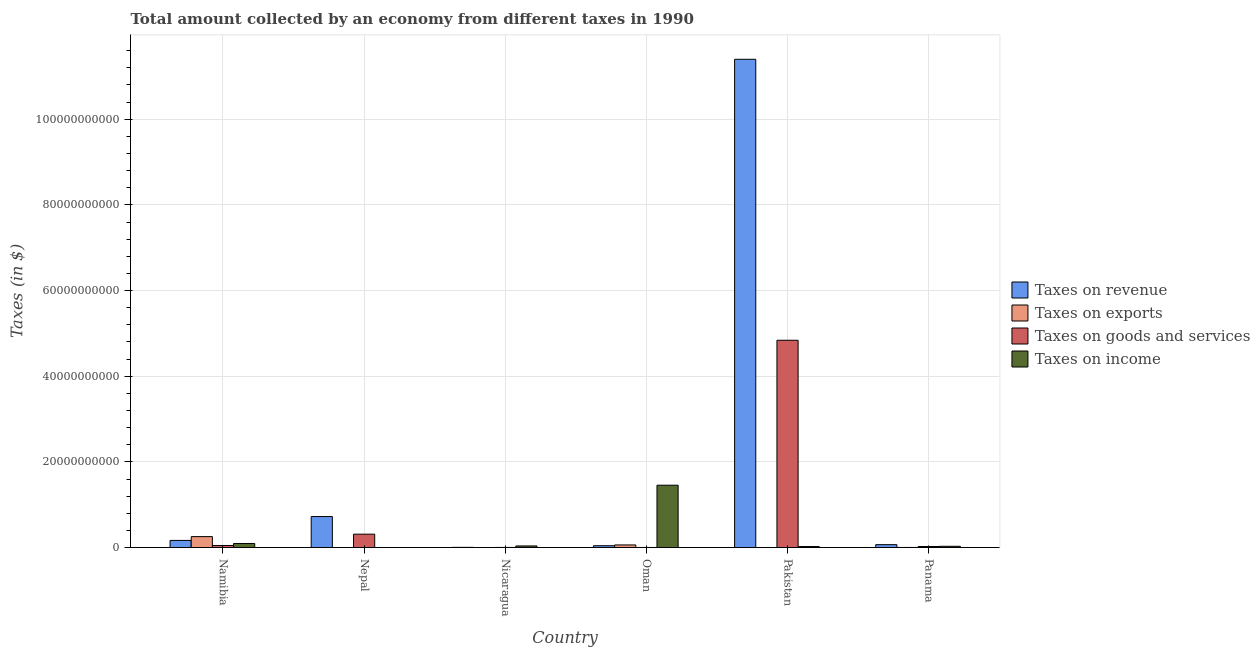How many different coloured bars are there?
Offer a terse response. 4. Are the number of bars per tick equal to the number of legend labels?
Make the answer very short. Yes. How many bars are there on the 5th tick from the right?
Your answer should be compact. 4. What is the label of the 6th group of bars from the left?
Your response must be concise. Panama. In how many cases, is the number of bars for a given country not equal to the number of legend labels?
Keep it short and to the point. 0. What is the amount collected as tax on income in Panama?
Your answer should be compact. 2.90e+08. Across all countries, what is the maximum amount collected as tax on income?
Ensure brevity in your answer.  1.46e+1. Across all countries, what is the minimum amount collected as tax on goods?
Provide a short and direct response. 1.10e+07. In which country was the amount collected as tax on exports minimum?
Make the answer very short. Nepal. What is the total amount collected as tax on goods in the graph?
Keep it short and to the point. 5.23e+1. What is the difference between the amount collected as tax on goods in Nepal and that in Pakistan?
Keep it short and to the point. -4.53e+1. What is the difference between the amount collected as tax on revenue in Oman and the amount collected as tax on exports in Nicaragua?
Give a very brief answer. 4.18e+08. What is the average amount collected as tax on exports per country?
Provide a succinct answer. 5.30e+08. What is the difference between the amount collected as tax on exports and amount collected as tax on income in Namibia?
Provide a succinct answer. 1.61e+09. In how many countries, is the amount collected as tax on goods greater than 32000000000 $?
Your answer should be very brief. 1. What is the ratio of the amount collected as tax on exports in Nicaragua to that in Panama?
Provide a succinct answer. 0.21. Is the difference between the amount collected as tax on income in Namibia and Oman greater than the difference between the amount collected as tax on goods in Namibia and Oman?
Your response must be concise. No. What is the difference between the highest and the second highest amount collected as tax on income?
Ensure brevity in your answer.  1.36e+1. What is the difference between the highest and the lowest amount collected as tax on exports?
Keep it short and to the point. 2.55e+09. In how many countries, is the amount collected as tax on exports greater than the average amount collected as tax on exports taken over all countries?
Your answer should be very brief. 2. What does the 1st bar from the left in Pakistan represents?
Give a very brief answer. Taxes on revenue. What does the 2nd bar from the right in Namibia represents?
Give a very brief answer. Taxes on goods and services. Are all the bars in the graph horizontal?
Your answer should be compact. No. How many countries are there in the graph?
Your answer should be compact. 6. Where does the legend appear in the graph?
Give a very brief answer. Center right. How many legend labels are there?
Provide a short and direct response. 4. What is the title of the graph?
Give a very brief answer. Total amount collected by an economy from different taxes in 1990. Does "Plant species" appear as one of the legend labels in the graph?
Ensure brevity in your answer.  No. What is the label or title of the X-axis?
Keep it short and to the point. Country. What is the label or title of the Y-axis?
Keep it short and to the point. Taxes (in $). What is the Taxes (in $) of Taxes on revenue in Namibia?
Ensure brevity in your answer.  1.66e+09. What is the Taxes (in $) in Taxes on exports in Namibia?
Your answer should be very brief. 2.55e+09. What is the Taxes (in $) of Taxes on goods and services in Namibia?
Provide a short and direct response. 4.80e+08. What is the Taxes (in $) in Taxes on income in Namibia?
Offer a very short reply. 9.43e+08. What is the Taxes (in $) of Taxes on revenue in Nepal?
Your answer should be very brief. 7.24e+09. What is the Taxes (in $) of Taxes on exports in Nepal?
Your answer should be very brief. 1.21e+06. What is the Taxes (in $) of Taxes on goods and services in Nepal?
Keep it short and to the point. 3.12e+09. What is the Taxes (in $) of Taxes on income in Nepal?
Ensure brevity in your answer.  9.16e+06. What is the Taxes (in $) of Taxes on revenue in Nicaragua?
Keep it short and to the point. 4.11e+07. What is the Taxes (in $) of Taxes on exports in Nicaragua?
Make the answer very short. 2.90e+06. What is the Taxes (in $) in Taxes on goods and services in Nicaragua?
Offer a terse response. 1.82e+07. What is the Taxes (in $) in Taxes on income in Nicaragua?
Ensure brevity in your answer.  3.68e+08. What is the Taxes (in $) of Taxes on revenue in Oman?
Provide a succinct answer. 4.21e+08. What is the Taxes (in $) in Taxes on exports in Oman?
Provide a succinct answer. 6.04e+08. What is the Taxes (in $) of Taxes on goods and services in Oman?
Offer a very short reply. 1.10e+07. What is the Taxes (in $) in Taxes on income in Oman?
Offer a very short reply. 1.46e+1. What is the Taxes (in $) in Taxes on revenue in Pakistan?
Give a very brief answer. 1.14e+11. What is the Taxes (in $) in Taxes on exports in Pakistan?
Provide a short and direct response. 9.40e+06. What is the Taxes (in $) in Taxes on goods and services in Pakistan?
Provide a short and direct response. 4.84e+1. What is the Taxes (in $) of Taxes on income in Pakistan?
Your answer should be very brief. 2.29e+08. What is the Taxes (in $) in Taxes on revenue in Panama?
Your answer should be very brief. 6.70e+08. What is the Taxes (in $) in Taxes on exports in Panama?
Provide a succinct answer. 1.40e+07. What is the Taxes (in $) of Taxes on goods and services in Panama?
Provide a short and direct response. 2.33e+08. What is the Taxes (in $) in Taxes on income in Panama?
Offer a terse response. 2.90e+08. Across all countries, what is the maximum Taxes (in $) in Taxes on revenue?
Your answer should be very brief. 1.14e+11. Across all countries, what is the maximum Taxes (in $) in Taxes on exports?
Offer a terse response. 2.55e+09. Across all countries, what is the maximum Taxes (in $) of Taxes on goods and services?
Your answer should be very brief. 4.84e+1. Across all countries, what is the maximum Taxes (in $) in Taxes on income?
Ensure brevity in your answer.  1.46e+1. Across all countries, what is the minimum Taxes (in $) of Taxes on revenue?
Your response must be concise. 4.11e+07. Across all countries, what is the minimum Taxes (in $) of Taxes on exports?
Keep it short and to the point. 1.21e+06. Across all countries, what is the minimum Taxes (in $) of Taxes on goods and services?
Provide a succinct answer. 1.10e+07. Across all countries, what is the minimum Taxes (in $) in Taxes on income?
Keep it short and to the point. 9.16e+06. What is the total Taxes (in $) of Taxes on revenue in the graph?
Ensure brevity in your answer.  1.24e+11. What is the total Taxes (in $) in Taxes on exports in the graph?
Provide a short and direct response. 3.18e+09. What is the total Taxes (in $) of Taxes on goods and services in the graph?
Keep it short and to the point. 5.23e+1. What is the total Taxes (in $) in Taxes on income in the graph?
Your answer should be very brief. 1.64e+1. What is the difference between the Taxes (in $) of Taxes on revenue in Namibia and that in Nepal?
Provide a short and direct response. -5.57e+09. What is the difference between the Taxes (in $) in Taxes on exports in Namibia and that in Nepal?
Provide a short and direct response. 2.55e+09. What is the difference between the Taxes (in $) of Taxes on goods and services in Namibia and that in Nepal?
Provide a short and direct response. -2.64e+09. What is the difference between the Taxes (in $) in Taxes on income in Namibia and that in Nepal?
Offer a very short reply. 9.34e+08. What is the difference between the Taxes (in $) of Taxes on revenue in Namibia and that in Nicaragua?
Offer a terse response. 1.62e+09. What is the difference between the Taxes (in $) in Taxes on exports in Namibia and that in Nicaragua?
Offer a very short reply. 2.55e+09. What is the difference between the Taxes (in $) in Taxes on goods and services in Namibia and that in Nicaragua?
Give a very brief answer. 4.61e+08. What is the difference between the Taxes (in $) in Taxes on income in Namibia and that in Nicaragua?
Offer a very short reply. 5.75e+08. What is the difference between the Taxes (in $) in Taxes on revenue in Namibia and that in Oman?
Give a very brief answer. 1.24e+09. What is the difference between the Taxes (in $) of Taxes on exports in Namibia and that in Oman?
Provide a succinct answer. 1.94e+09. What is the difference between the Taxes (in $) in Taxes on goods and services in Namibia and that in Oman?
Offer a very short reply. 4.68e+08. What is the difference between the Taxes (in $) of Taxes on income in Namibia and that in Oman?
Ensure brevity in your answer.  -1.36e+1. What is the difference between the Taxes (in $) of Taxes on revenue in Namibia and that in Pakistan?
Provide a short and direct response. -1.12e+11. What is the difference between the Taxes (in $) in Taxes on exports in Namibia and that in Pakistan?
Make the answer very short. 2.54e+09. What is the difference between the Taxes (in $) of Taxes on goods and services in Namibia and that in Pakistan?
Provide a short and direct response. -4.79e+1. What is the difference between the Taxes (in $) of Taxes on income in Namibia and that in Pakistan?
Provide a succinct answer. 7.14e+08. What is the difference between the Taxes (in $) in Taxes on revenue in Namibia and that in Panama?
Offer a terse response. 9.91e+08. What is the difference between the Taxes (in $) in Taxes on exports in Namibia and that in Panama?
Offer a terse response. 2.54e+09. What is the difference between the Taxes (in $) in Taxes on goods and services in Namibia and that in Panama?
Keep it short and to the point. 2.47e+08. What is the difference between the Taxes (in $) of Taxes on income in Namibia and that in Panama?
Provide a succinct answer. 6.53e+08. What is the difference between the Taxes (in $) of Taxes on revenue in Nepal and that in Nicaragua?
Make the answer very short. 7.19e+09. What is the difference between the Taxes (in $) of Taxes on exports in Nepal and that in Nicaragua?
Make the answer very short. -1.69e+06. What is the difference between the Taxes (in $) of Taxes on goods and services in Nepal and that in Nicaragua?
Offer a very short reply. 3.10e+09. What is the difference between the Taxes (in $) of Taxes on income in Nepal and that in Nicaragua?
Offer a very short reply. -3.59e+08. What is the difference between the Taxes (in $) in Taxes on revenue in Nepal and that in Oman?
Keep it short and to the point. 6.82e+09. What is the difference between the Taxes (in $) of Taxes on exports in Nepal and that in Oman?
Your answer should be very brief. -6.03e+08. What is the difference between the Taxes (in $) of Taxes on goods and services in Nepal and that in Oman?
Offer a very short reply. 3.11e+09. What is the difference between the Taxes (in $) of Taxes on income in Nepal and that in Oman?
Your response must be concise. -1.45e+1. What is the difference between the Taxes (in $) in Taxes on revenue in Nepal and that in Pakistan?
Provide a succinct answer. -1.07e+11. What is the difference between the Taxes (in $) in Taxes on exports in Nepal and that in Pakistan?
Keep it short and to the point. -8.19e+06. What is the difference between the Taxes (in $) of Taxes on goods and services in Nepal and that in Pakistan?
Provide a succinct answer. -4.53e+1. What is the difference between the Taxes (in $) in Taxes on income in Nepal and that in Pakistan?
Provide a succinct answer. -2.20e+08. What is the difference between the Taxes (in $) in Taxes on revenue in Nepal and that in Panama?
Give a very brief answer. 6.57e+09. What is the difference between the Taxes (in $) in Taxes on exports in Nepal and that in Panama?
Your response must be concise. -1.28e+07. What is the difference between the Taxes (in $) in Taxes on goods and services in Nepal and that in Panama?
Offer a terse response. 2.89e+09. What is the difference between the Taxes (in $) in Taxes on income in Nepal and that in Panama?
Make the answer very short. -2.81e+08. What is the difference between the Taxes (in $) in Taxes on revenue in Nicaragua and that in Oman?
Your answer should be very brief. -3.80e+08. What is the difference between the Taxes (in $) in Taxes on exports in Nicaragua and that in Oman?
Make the answer very short. -6.01e+08. What is the difference between the Taxes (in $) in Taxes on goods and services in Nicaragua and that in Oman?
Provide a short and direct response. 7.18e+06. What is the difference between the Taxes (in $) in Taxes on income in Nicaragua and that in Oman?
Offer a terse response. -1.42e+1. What is the difference between the Taxes (in $) in Taxes on revenue in Nicaragua and that in Pakistan?
Offer a very short reply. -1.14e+11. What is the difference between the Taxes (in $) of Taxes on exports in Nicaragua and that in Pakistan?
Keep it short and to the point. -6.50e+06. What is the difference between the Taxes (in $) of Taxes on goods and services in Nicaragua and that in Pakistan?
Provide a succinct answer. -4.84e+1. What is the difference between the Taxes (in $) in Taxes on income in Nicaragua and that in Pakistan?
Make the answer very short. 1.39e+08. What is the difference between the Taxes (in $) in Taxes on revenue in Nicaragua and that in Panama?
Your answer should be very brief. -6.29e+08. What is the difference between the Taxes (in $) in Taxes on exports in Nicaragua and that in Panama?
Offer a very short reply. -1.11e+07. What is the difference between the Taxes (in $) in Taxes on goods and services in Nicaragua and that in Panama?
Provide a succinct answer. -2.14e+08. What is the difference between the Taxes (in $) of Taxes on income in Nicaragua and that in Panama?
Give a very brief answer. 7.82e+07. What is the difference between the Taxes (in $) in Taxes on revenue in Oman and that in Pakistan?
Provide a short and direct response. -1.14e+11. What is the difference between the Taxes (in $) of Taxes on exports in Oman and that in Pakistan?
Your response must be concise. 5.95e+08. What is the difference between the Taxes (in $) in Taxes on goods and services in Oman and that in Pakistan?
Your answer should be compact. -4.84e+1. What is the difference between the Taxes (in $) in Taxes on income in Oman and that in Pakistan?
Offer a very short reply. 1.43e+1. What is the difference between the Taxes (in $) of Taxes on revenue in Oman and that in Panama?
Make the answer very short. -2.49e+08. What is the difference between the Taxes (in $) in Taxes on exports in Oman and that in Panama?
Make the answer very short. 5.90e+08. What is the difference between the Taxes (in $) of Taxes on goods and services in Oman and that in Panama?
Offer a terse response. -2.22e+08. What is the difference between the Taxes (in $) of Taxes on income in Oman and that in Panama?
Make the answer very short. 1.43e+1. What is the difference between the Taxes (in $) of Taxes on revenue in Pakistan and that in Panama?
Provide a short and direct response. 1.13e+11. What is the difference between the Taxes (in $) of Taxes on exports in Pakistan and that in Panama?
Ensure brevity in your answer.  -4.60e+06. What is the difference between the Taxes (in $) of Taxes on goods and services in Pakistan and that in Panama?
Your answer should be very brief. 4.82e+1. What is the difference between the Taxes (in $) of Taxes on income in Pakistan and that in Panama?
Make the answer very short. -6.08e+07. What is the difference between the Taxes (in $) in Taxes on revenue in Namibia and the Taxes (in $) in Taxes on exports in Nepal?
Make the answer very short. 1.66e+09. What is the difference between the Taxes (in $) in Taxes on revenue in Namibia and the Taxes (in $) in Taxes on goods and services in Nepal?
Provide a succinct answer. -1.46e+09. What is the difference between the Taxes (in $) in Taxes on revenue in Namibia and the Taxes (in $) in Taxes on income in Nepal?
Your answer should be compact. 1.65e+09. What is the difference between the Taxes (in $) in Taxes on exports in Namibia and the Taxes (in $) in Taxes on goods and services in Nepal?
Offer a terse response. -5.70e+08. What is the difference between the Taxes (in $) of Taxes on exports in Namibia and the Taxes (in $) of Taxes on income in Nepal?
Give a very brief answer. 2.54e+09. What is the difference between the Taxes (in $) of Taxes on goods and services in Namibia and the Taxes (in $) of Taxes on income in Nepal?
Make the answer very short. 4.70e+08. What is the difference between the Taxes (in $) in Taxes on revenue in Namibia and the Taxes (in $) in Taxes on exports in Nicaragua?
Provide a short and direct response. 1.66e+09. What is the difference between the Taxes (in $) of Taxes on revenue in Namibia and the Taxes (in $) of Taxes on goods and services in Nicaragua?
Offer a terse response. 1.64e+09. What is the difference between the Taxes (in $) of Taxes on revenue in Namibia and the Taxes (in $) of Taxes on income in Nicaragua?
Your answer should be compact. 1.29e+09. What is the difference between the Taxes (in $) of Taxes on exports in Namibia and the Taxes (in $) of Taxes on goods and services in Nicaragua?
Your answer should be compact. 2.53e+09. What is the difference between the Taxes (in $) of Taxes on exports in Namibia and the Taxes (in $) of Taxes on income in Nicaragua?
Your answer should be very brief. 2.18e+09. What is the difference between the Taxes (in $) in Taxes on goods and services in Namibia and the Taxes (in $) in Taxes on income in Nicaragua?
Provide a succinct answer. 1.11e+08. What is the difference between the Taxes (in $) in Taxes on revenue in Namibia and the Taxes (in $) in Taxes on exports in Oman?
Your response must be concise. 1.06e+09. What is the difference between the Taxes (in $) in Taxes on revenue in Namibia and the Taxes (in $) in Taxes on goods and services in Oman?
Ensure brevity in your answer.  1.65e+09. What is the difference between the Taxes (in $) of Taxes on revenue in Namibia and the Taxes (in $) of Taxes on income in Oman?
Your answer should be compact. -1.29e+1. What is the difference between the Taxes (in $) in Taxes on exports in Namibia and the Taxes (in $) in Taxes on goods and services in Oman?
Offer a very short reply. 2.54e+09. What is the difference between the Taxes (in $) in Taxes on exports in Namibia and the Taxes (in $) in Taxes on income in Oman?
Make the answer very short. -1.20e+1. What is the difference between the Taxes (in $) in Taxes on goods and services in Namibia and the Taxes (in $) in Taxes on income in Oman?
Keep it short and to the point. -1.41e+1. What is the difference between the Taxes (in $) in Taxes on revenue in Namibia and the Taxes (in $) in Taxes on exports in Pakistan?
Give a very brief answer. 1.65e+09. What is the difference between the Taxes (in $) in Taxes on revenue in Namibia and the Taxes (in $) in Taxes on goods and services in Pakistan?
Give a very brief answer. -4.67e+1. What is the difference between the Taxes (in $) in Taxes on revenue in Namibia and the Taxes (in $) in Taxes on income in Pakistan?
Your answer should be compact. 1.43e+09. What is the difference between the Taxes (in $) of Taxes on exports in Namibia and the Taxes (in $) of Taxes on goods and services in Pakistan?
Offer a very short reply. -4.58e+1. What is the difference between the Taxes (in $) of Taxes on exports in Namibia and the Taxes (in $) of Taxes on income in Pakistan?
Offer a very short reply. 2.32e+09. What is the difference between the Taxes (in $) of Taxes on goods and services in Namibia and the Taxes (in $) of Taxes on income in Pakistan?
Your response must be concise. 2.50e+08. What is the difference between the Taxes (in $) of Taxes on revenue in Namibia and the Taxes (in $) of Taxes on exports in Panama?
Provide a succinct answer. 1.65e+09. What is the difference between the Taxes (in $) in Taxes on revenue in Namibia and the Taxes (in $) in Taxes on goods and services in Panama?
Provide a short and direct response. 1.43e+09. What is the difference between the Taxes (in $) of Taxes on revenue in Namibia and the Taxes (in $) of Taxes on income in Panama?
Keep it short and to the point. 1.37e+09. What is the difference between the Taxes (in $) of Taxes on exports in Namibia and the Taxes (in $) of Taxes on goods and services in Panama?
Ensure brevity in your answer.  2.32e+09. What is the difference between the Taxes (in $) of Taxes on exports in Namibia and the Taxes (in $) of Taxes on income in Panama?
Give a very brief answer. 2.26e+09. What is the difference between the Taxes (in $) in Taxes on goods and services in Namibia and the Taxes (in $) in Taxes on income in Panama?
Give a very brief answer. 1.89e+08. What is the difference between the Taxes (in $) of Taxes on revenue in Nepal and the Taxes (in $) of Taxes on exports in Nicaragua?
Your answer should be very brief. 7.23e+09. What is the difference between the Taxes (in $) in Taxes on revenue in Nepal and the Taxes (in $) in Taxes on goods and services in Nicaragua?
Provide a succinct answer. 7.22e+09. What is the difference between the Taxes (in $) of Taxes on revenue in Nepal and the Taxes (in $) of Taxes on income in Nicaragua?
Your answer should be very brief. 6.87e+09. What is the difference between the Taxes (in $) in Taxes on exports in Nepal and the Taxes (in $) in Taxes on goods and services in Nicaragua?
Give a very brief answer. -1.70e+07. What is the difference between the Taxes (in $) of Taxes on exports in Nepal and the Taxes (in $) of Taxes on income in Nicaragua?
Offer a terse response. -3.67e+08. What is the difference between the Taxes (in $) of Taxes on goods and services in Nepal and the Taxes (in $) of Taxes on income in Nicaragua?
Offer a terse response. 2.75e+09. What is the difference between the Taxes (in $) of Taxes on revenue in Nepal and the Taxes (in $) of Taxes on exports in Oman?
Give a very brief answer. 6.63e+09. What is the difference between the Taxes (in $) in Taxes on revenue in Nepal and the Taxes (in $) in Taxes on goods and services in Oman?
Your answer should be very brief. 7.22e+09. What is the difference between the Taxes (in $) in Taxes on revenue in Nepal and the Taxes (in $) in Taxes on income in Oman?
Provide a succinct answer. -7.32e+09. What is the difference between the Taxes (in $) in Taxes on exports in Nepal and the Taxes (in $) in Taxes on goods and services in Oman?
Your answer should be very brief. -9.79e+06. What is the difference between the Taxes (in $) of Taxes on exports in Nepal and the Taxes (in $) of Taxes on income in Oman?
Keep it short and to the point. -1.45e+1. What is the difference between the Taxes (in $) of Taxes on goods and services in Nepal and the Taxes (in $) of Taxes on income in Oman?
Ensure brevity in your answer.  -1.14e+1. What is the difference between the Taxes (in $) in Taxes on revenue in Nepal and the Taxes (in $) in Taxes on exports in Pakistan?
Ensure brevity in your answer.  7.23e+09. What is the difference between the Taxes (in $) of Taxes on revenue in Nepal and the Taxes (in $) of Taxes on goods and services in Pakistan?
Provide a succinct answer. -4.12e+1. What is the difference between the Taxes (in $) of Taxes on revenue in Nepal and the Taxes (in $) of Taxes on income in Pakistan?
Offer a very short reply. 7.01e+09. What is the difference between the Taxes (in $) of Taxes on exports in Nepal and the Taxes (in $) of Taxes on goods and services in Pakistan?
Give a very brief answer. -4.84e+1. What is the difference between the Taxes (in $) in Taxes on exports in Nepal and the Taxes (in $) in Taxes on income in Pakistan?
Offer a very short reply. -2.28e+08. What is the difference between the Taxes (in $) of Taxes on goods and services in Nepal and the Taxes (in $) of Taxes on income in Pakistan?
Offer a terse response. 2.89e+09. What is the difference between the Taxes (in $) of Taxes on revenue in Nepal and the Taxes (in $) of Taxes on exports in Panama?
Your response must be concise. 7.22e+09. What is the difference between the Taxes (in $) of Taxes on revenue in Nepal and the Taxes (in $) of Taxes on goods and services in Panama?
Offer a very short reply. 7.00e+09. What is the difference between the Taxes (in $) of Taxes on revenue in Nepal and the Taxes (in $) of Taxes on income in Panama?
Give a very brief answer. 6.95e+09. What is the difference between the Taxes (in $) of Taxes on exports in Nepal and the Taxes (in $) of Taxes on goods and services in Panama?
Provide a succinct answer. -2.31e+08. What is the difference between the Taxes (in $) in Taxes on exports in Nepal and the Taxes (in $) in Taxes on income in Panama?
Keep it short and to the point. -2.89e+08. What is the difference between the Taxes (in $) of Taxes on goods and services in Nepal and the Taxes (in $) of Taxes on income in Panama?
Your response must be concise. 2.83e+09. What is the difference between the Taxes (in $) of Taxes on revenue in Nicaragua and the Taxes (in $) of Taxes on exports in Oman?
Give a very brief answer. -5.63e+08. What is the difference between the Taxes (in $) of Taxes on revenue in Nicaragua and the Taxes (in $) of Taxes on goods and services in Oman?
Offer a terse response. 3.01e+07. What is the difference between the Taxes (in $) in Taxes on revenue in Nicaragua and the Taxes (in $) in Taxes on income in Oman?
Ensure brevity in your answer.  -1.45e+1. What is the difference between the Taxes (in $) of Taxes on exports in Nicaragua and the Taxes (in $) of Taxes on goods and services in Oman?
Offer a terse response. -8.10e+06. What is the difference between the Taxes (in $) in Taxes on exports in Nicaragua and the Taxes (in $) in Taxes on income in Oman?
Offer a very short reply. -1.45e+1. What is the difference between the Taxes (in $) of Taxes on goods and services in Nicaragua and the Taxes (in $) of Taxes on income in Oman?
Your answer should be very brief. -1.45e+1. What is the difference between the Taxes (in $) of Taxes on revenue in Nicaragua and the Taxes (in $) of Taxes on exports in Pakistan?
Your answer should be very brief. 3.17e+07. What is the difference between the Taxes (in $) of Taxes on revenue in Nicaragua and the Taxes (in $) of Taxes on goods and services in Pakistan?
Your answer should be very brief. -4.84e+1. What is the difference between the Taxes (in $) in Taxes on revenue in Nicaragua and the Taxes (in $) in Taxes on income in Pakistan?
Your answer should be compact. -1.88e+08. What is the difference between the Taxes (in $) of Taxes on exports in Nicaragua and the Taxes (in $) of Taxes on goods and services in Pakistan?
Offer a very short reply. -4.84e+1. What is the difference between the Taxes (in $) in Taxes on exports in Nicaragua and the Taxes (in $) in Taxes on income in Pakistan?
Your answer should be compact. -2.26e+08. What is the difference between the Taxes (in $) of Taxes on goods and services in Nicaragua and the Taxes (in $) of Taxes on income in Pakistan?
Keep it short and to the point. -2.11e+08. What is the difference between the Taxes (in $) in Taxes on revenue in Nicaragua and the Taxes (in $) in Taxes on exports in Panama?
Keep it short and to the point. 2.71e+07. What is the difference between the Taxes (in $) in Taxes on revenue in Nicaragua and the Taxes (in $) in Taxes on goods and services in Panama?
Provide a succinct answer. -1.92e+08. What is the difference between the Taxes (in $) of Taxes on revenue in Nicaragua and the Taxes (in $) of Taxes on income in Panama?
Provide a succinct answer. -2.49e+08. What is the difference between the Taxes (in $) of Taxes on exports in Nicaragua and the Taxes (in $) of Taxes on goods and services in Panama?
Give a very brief answer. -2.30e+08. What is the difference between the Taxes (in $) in Taxes on exports in Nicaragua and the Taxes (in $) in Taxes on income in Panama?
Your answer should be compact. -2.87e+08. What is the difference between the Taxes (in $) in Taxes on goods and services in Nicaragua and the Taxes (in $) in Taxes on income in Panama?
Keep it short and to the point. -2.72e+08. What is the difference between the Taxes (in $) in Taxes on revenue in Oman and the Taxes (in $) in Taxes on exports in Pakistan?
Your response must be concise. 4.11e+08. What is the difference between the Taxes (in $) of Taxes on revenue in Oman and the Taxes (in $) of Taxes on goods and services in Pakistan?
Give a very brief answer. -4.80e+1. What is the difference between the Taxes (in $) in Taxes on revenue in Oman and the Taxes (in $) in Taxes on income in Pakistan?
Offer a terse response. 1.91e+08. What is the difference between the Taxes (in $) of Taxes on exports in Oman and the Taxes (in $) of Taxes on goods and services in Pakistan?
Offer a very short reply. -4.78e+1. What is the difference between the Taxes (in $) of Taxes on exports in Oman and the Taxes (in $) of Taxes on income in Pakistan?
Offer a very short reply. 3.75e+08. What is the difference between the Taxes (in $) of Taxes on goods and services in Oman and the Taxes (in $) of Taxes on income in Pakistan?
Ensure brevity in your answer.  -2.18e+08. What is the difference between the Taxes (in $) in Taxes on revenue in Oman and the Taxes (in $) in Taxes on exports in Panama?
Provide a succinct answer. 4.07e+08. What is the difference between the Taxes (in $) in Taxes on revenue in Oman and the Taxes (in $) in Taxes on goods and services in Panama?
Provide a short and direct response. 1.88e+08. What is the difference between the Taxes (in $) of Taxes on revenue in Oman and the Taxes (in $) of Taxes on income in Panama?
Your answer should be very brief. 1.30e+08. What is the difference between the Taxes (in $) in Taxes on exports in Oman and the Taxes (in $) in Taxes on goods and services in Panama?
Provide a succinct answer. 3.71e+08. What is the difference between the Taxes (in $) in Taxes on exports in Oman and the Taxes (in $) in Taxes on income in Panama?
Provide a short and direct response. 3.14e+08. What is the difference between the Taxes (in $) in Taxes on goods and services in Oman and the Taxes (in $) in Taxes on income in Panama?
Your answer should be compact. -2.79e+08. What is the difference between the Taxes (in $) in Taxes on revenue in Pakistan and the Taxes (in $) in Taxes on exports in Panama?
Keep it short and to the point. 1.14e+11. What is the difference between the Taxes (in $) in Taxes on revenue in Pakistan and the Taxes (in $) in Taxes on goods and services in Panama?
Your answer should be very brief. 1.14e+11. What is the difference between the Taxes (in $) of Taxes on revenue in Pakistan and the Taxes (in $) of Taxes on income in Panama?
Ensure brevity in your answer.  1.14e+11. What is the difference between the Taxes (in $) in Taxes on exports in Pakistan and the Taxes (in $) in Taxes on goods and services in Panama?
Your answer should be very brief. -2.23e+08. What is the difference between the Taxes (in $) of Taxes on exports in Pakistan and the Taxes (in $) of Taxes on income in Panama?
Provide a short and direct response. -2.81e+08. What is the difference between the Taxes (in $) in Taxes on goods and services in Pakistan and the Taxes (in $) in Taxes on income in Panama?
Make the answer very short. 4.81e+1. What is the average Taxes (in $) in Taxes on revenue per country?
Give a very brief answer. 2.07e+1. What is the average Taxes (in $) in Taxes on exports per country?
Give a very brief answer. 5.30e+08. What is the average Taxes (in $) in Taxes on goods and services per country?
Your answer should be compact. 8.71e+09. What is the average Taxes (in $) in Taxes on income per country?
Keep it short and to the point. 2.73e+09. What is the difference between the Taxes (in $) in Taxes on revenue and Taxes (in $) in Taxes on exports in Namibia?
Ensure brevity in your answer.  -8.88e+08. What is the difference between the Taxes (in $) of Taxes on revenue and Taxes (in $) of Taxes on goods and services in Namibia?
Ensure brevity in your answer.  1.18e+09. What is the difference between the Taxes (in $) of Taxes on revenue and Taxes (in $) of Taxes on income in Namibia?
Make the answer very short. 7.18e+08. What is the difference between the Taxes (in $) in Taxes on exports and Taxes (in $) in Taxes on goods and services in Namibia?
Ensure brevity in your answer.  2.07e+09. What is the difference between the Taxes (in $) in Taxes on exports and Taxes (in $) in Taxes on income in Namibia?
Your answer should be compact. 1.61e+09. What is the difference between the Taxes (in $) in Taxes on goods and services and Taxes (in $) in Taxes on income in Namibia?
Make the answer very short. -4.64e+08. What is the difference between the Taxes (in $) in Taxes on revenue and Taxes (in $) in Taxes on exports in Nepal?
Offer a very short reply. 7.23e+09. What is the difference between the Taxes (in $) of Taxes on revenue and Taxes (in $) of Taxes on goods and services in Nepal?
Your answer should be very brief. 4.12e+09. What is the difference between the Taxes (in $) in Taxes on revenue and Taxes (in $) in Taxes on income in Nepal?
Ensure brevity in your answer.  7.23e+09. What is the difference between the Taxes (in $) of Taxes on exports and Taxes (in $) of Taxes on goods and services in Nepal?
Provide a short and direct response. -3.12e+09. What is the difference between the Taxes (in $) in Taxes on exports and Taxes (in $) in Taxes on income in Nepal?
Provide a short and direct response. -7.95e+06. What is the difference between the Taxes (in $) in Taxes on goods and services and Taxes (in $) in Taxes on income in Nepal?
Provide a succinct answer. 3.11e+09. What is the difference between the Taxes (in $) in Taxes on revenue and Taxes (in $) in Taxes on exports in Nicaragua?
Offer a very short reply. 3.82e+07. What is the difference between the Taxes (in $) in Taxes on revenue and Taxes (in $) in Taxes on goods and services in Nicaragua?
Your answer should be very brief. 2.29e+07. What is the difference between the Taxes (in $) in Taxes on revenue and Taxes (in $) in Taxes on income in Nicaragua?
Your answer should be compact. -3.27e+08. What is the difference between the Taxes (in $) in Taxes on exports and Taxes (in $) in Taxes on goods and services in Nicaragua?
Your answer should be compact. -1.53e+07. What is the difference between the Taxes (in $) in Taxes on exports and Taxes (in $) in Taxes on income in Nicaragua?
Provide a short and direct response. -3.66e+08. What is the difference between the Taxes (in $) of Taxes on goods and services and Taxes (in $) of Taxes on income in Nicaragua?
Keep it short and to the point. -3.50e+08. What is the difference between the Taxes (in $) in Taxes on revenue and Taxes (in $) in Taxes on exports in Oman?
Provide a short and direct response. -1.83e+08. What is the difference between the Taxes (in $) of Taxes on revenue and Taxes (in $) of Taxes on goods and services in Oman?
Provide a short and direct response. 4.10e+08. What is the difference between the Taxes (in $) in Taxes on revenue and Taxes (in $) in Taxes on income in Oman?
Keep it short and to the point. -1.41e+1. What is the difference between the Taxes (in $) in Taxes on exports and Taxes (in $) in Taxes on goods and services in Oman?
Your response must be concise. 5.93e+08. What is the difference between the Taxes (in $) in Taxes on exports and Taxes (in $) in Taxes on income in Oman?
Make the answer very short. -1.39e+1. What is the difference between the Taxes (in $) in Taxes on goods and services and Taxes (in $) in Taxes on income in Oman?
Give a very brief answer. -1.45e+1. What is the difference between the Taxes (in $) in Taxes on revenue and Taxes (in $) in Taxes on exports in Pakistan?
Provide a short and direct response. 1.14e+11. What is the difference between the Taxes (in $) of Taxes on revenue and Taxes (in $) of Taxes on goods and services in Pakistan?
Your answer should be very brief. 6.56e+1. What is the difference between the Taxes (in $) in Taxes on revenue and Taxes (in $) in Taxes on income in Pakistan?
Provide a succinct answer. 1.14e+11. What is the difference between the Taxes (in $) in Taxes on exports and Taxes (in $) in Taxes on goods and services in Pakistan?
Keep it short and to the point. -4.84e+1. What is the difference between the Taxes (in $) in Taxes on exports and Taxes (in $) in Taxes on income in Pakistan?
Ensure brevity in your answer.  -2.20e+08. What is the difference between the Taxes (in $) of Taxes on goods and services and Taxes (in $) of Taxes on income in Pakistan?
Give a very brief answer. 4.82e+1. What is the difference between the Taxes (in $) in Taxes on revenue and Taxes (in $) in Taxes on exports in Panama?
Offer a very short reply. 6.56e+08. What is the difference between the Taxes (in $) of Taxes on revenue and Taxes (in $) of Taxes on goods and services in Panama?
Ensure brevity in your answer.  4.37e+08. What is the difference between the Taxes (in $) of Taxes on revenue and Taxes (in $) of Taxes on income in Panama?
Give a very brief answer. 3.80e+08. What is the difference between the Taxes (in $) of Taxes on exports and Taxes (in $) of Taxes on goods and services in Panama?
Offer a very short reply. -2.19e+08. What is the difference between the Taxes (in $) of Taxes on exports and Taxes (in $) of Taxes on income in Panama?
Offer a very short reply. -2.76e+08. What is the difference between the Taxes (in $) of Taxes on goods and services and Taxes (in $) of Taxes on income in Panama?
Offer a terse response. -5.76e+07. What is the ratio of the Taxes (in $) of Taxes on revenue in Namibia to that in Nepal?
Provide a short and direct response. 0.23. What is the ratio of the Taxes (in $) of Taxes on exports in Namibia to that in Nepal?
Offer a very short reply. 2106.61. What is the ratio of the Taxes (in $) of Taxes on goods and services in Namibia to that in Nepal?
Offer a very short reply. 0.15. What is the ratio of the Taxes (in $) of Taxes on income in Namibia to that in Nepal?
Offer a terse response. 102.95. What is the ratio of the Taxes (in $) in Taxes on revenue in Namibia to that in Nicaragua?
Offer a very short reply. 40.42. What is the ratio of the Taxes (in $) in Taxes on exports in Namibia to that in Nicaragua?
Offer a very short reply. 878.97. What is the ratio of the Taxes (in $) in Taxes on goods and services in Namibia to that in Nicaragua?
Ensure brevity in your answer.  26.38. What is the ratio of the Taxes (in $) in Taxes on income in Namibia to that in Nicaragua?
Your answer should be compact. 2.56. What is the ratio of the Taxes (in $) in Taxes on revenue in Namibia to that in Oman?
Offer a terse response. 3.95. What is the ratio of the Taxes (in $) of Taxes on exports in Namibia to that in Oman?
Ensure brevity in your answer.  4.22. What is the ratio of the Taxes (in $) in Taxes on goods and services in Namibia to that in Oman?
Ensure brevity in your answer.  43.59. What is the ratio of the Taxes (in $) in Taxes on income in Namibia to that in Oman?
Your response must be concise. 0.06. What is the ratio of the Taxes (in $) of Taxes on revenue in Namibia to that in Pakistan?
Your answer should be compact. 0.01. What is the ratio of the Taxes (in $) of Taxes on exports in Namibia to that in Pakistan?
Offer a terse response. 271.17. What is the ratio of the Taxes (in $) of Taxes on goods and services in Namibia to that in Pakistan?
Your answer should be very brief. 0.01. What is the ratio of the Taxes (in $) in Taxes on income in Namibia to that in Pakistan?
Provide a succinct answer. 4.11. What is the ratio of the Taxes (in $) in Taxes on revenue in Namibia to that in Panama?
Keep it short and to the point. 2.48. What is the ratio of the Taxes (in $) in Taxes on exports in Namibia to that in Panama?
Make the answer very short. 182.07. What is the ratio of the Taxes (in $) in Taxes on goods and services in Namibia to that in Panama?
Your answer should be compact. 2.06. What is the ratio of the Taxes (in $) in Taxes on income in Namibia to that in Panama?
Provide a short and direct response. 3.25. What is the ratio of the Taxes (in $) in Taxes on revenue in Nepal to that in Nicaragua?
Your answer should be very brief. 176.06. What is the ratio of the Taxes (in $) of Taxes on exports in Nepal to that in Nicaragua?
Keep it short and to the point. 0.42. What is the ratio of the Taxes (in $) in Taxes on goods and services in Nepal to that in Nicaragua?
Offer a very short reply. 171.56. What is the ratio of the Taxes (in $) in Taxes on income in Nepal to that in Nicaragua?
Provide a succinct answer. 0.02. What is the ratio of the Taxes (in $) of Taxes on revenue in Nepal to that in Oman?
Make the answer very short. 17.2. What is the ratio of the Taxes (in $) in Taxes on exports in Nepal to that in Oman?
Give a very brief answer. 0. What is the ratio of the Taxes (in $) in Taxes on goods and services in Nepal to that in Oman?
Provide a succinct answer. 283.54. What is the ratio of the Taxes (in $) in Taxes on income in Nepal to that in Oman?
Your response must be concise. 0. What is the ratio of the Taxes (in $) of Taxes on revenue in Nepal to that in Pakistan?
Offer a terse response. 0.06. What is the ratio of the Taxes (in $) in Taxes on exports in Nepal to that in Pakistan?
Keep it short and to the point. 0.13. What is the ratio of the Taxes (in $) in Taxes on goods and services in Nepal to that in Pakistan?
Your answer should be very brief. 0.06. What is the ratio of the Taxes (in $) in Taxes on income in Nepal to that in Pakistan?
Offer a very short reply. 0.04. What is the ratio of the Taxes (in $) of Taxes on revenue in Nepal to that in Panama?
Offer a terse response. 10.8. What is the ratio of the Taxes (in $) of Taxes on exports in Nepal to that in Panama?
Provide a short and direct response. 0.09. What is the ratio of the Taxes (in $) in Taxes on goods and services in Nepal to that in Panama?
Make the answer very short. 13.41. What is the ratio of the Taxes (in $) in Taxes on income in Nepal to that in Panama?
Offer a terse response. 0.03. What is the ratio of the Taxes (in $) in Taxes on revenue in Nicaragua to that in Oman?
Your response must be concise. 0.1. What is the ratio of the Taxes (in $) of Taxes on exports in Nicaragua to that in Oman?
Ensure brevity in your answer.  0. What is the ratio of the Taxes (in $) in Taxes on goods and services in Nicaragua to that in Oman?
Provide a short and direct response. 1.65. What is the ratio of the Taxes (in $) of Taxes on income in Nicaragua to that in Oman?
Offer a very short reply. 0.03. What is the ratio of the Taxes (in $) of Taxes on revenue in Nicaragua to that in Pakistan?
Ensure brevity in your answer.  0. What is the ratio of the Taxes (in $) of Taxes on exports in Nicaragua to that in Pakistan?
Provide a succinct answer. 0.31. What is the ratio of the Taxes (in $) in Taxes on goods and services in Nicaragua to that in Pakistan?
Your answer should be very brief. 0. What is the ratio of the Taxes (in $) in Taxes on income in Nicaragua to that in Pakistan?
Provide a succinct answer. 1.61. What is the ratio of the Taxes (in $) of Taxes on revenue in Nicaragua to that in Panama?
Keep it short and to the point. 0.06. What is the ratio of the Taxes (in $) in Taxes on exports in Nicaragua to that in Panama?
Your answer should be very brief. 0.21. What is the ratio of the Taxes (in $) of Taxes on goods and services in Nicaragua to that in Panama?
Your response must be concise. 0.08. What is the ratio of the Taxes (in $) in Taxes on income in Nicaragua to that in Panama?
Your answer should be compact. 1.27. What is the ratio of the Taxes (in $) in Taxes on revenue in Oman to that in Pakistan?
Make the answer very short. 0. What is the ratio of the Taxes (in $) in Taxes on exports in Oman to that in Pakistan?
Your response must be concise. 64.26. What is the ratio of the Taxes (in $) of Taxes on income in Oman to that in Pakistan?
Your answer should be very brief. 63.43. What is the ratio of the Taxes (in $) of Taxes on revenue in Oman to that in Panama?
Provide a succinct answer. 0.63. What is the ratio of the Taxes (in $) in Taxes on exports in Oman to that in Panama?
Offer a very short reply. 43.14. What is the ratio of the Taxes (in $) of Taxes on goods and services in Oman to that in Panama?
Offer a very short reply. 0.05. What is the ratio of the Taxes (in $) of Taxes on income in Oman to that in Panama?
Offer a very short reply. 50.15. What is the ratio of the Taxes (in $) of Taxes on revenue in Pakistan to that in Panama?
Make the answer very short. 170.16. What is the ratio of the Taxes (in $) of Taxes on exports in Pakistan to that in Panama?
Provide a succinct answer. 0.67. What is the ratio of the Taxes (in $) of Taxes on goods and services in Pakistan to that in Panama?
Give a very brief answer. 208.07. What is the ratio of the Taxes (in $) of Taxes on income in Pakistan to that in Panama?
Your answer should be compact. 0.79. What is the difference between the highest and the second highest Taxes (in $) of Taxes on revenue?
Your answer should be compact. 1.07e+11. What is the difference between the highest and the second highest Taxes (in $) of Taxes on exports?
Provide a succinct answer. 1.94e+09. What is the difference between the highest and the second highest Taxes (in $) in Taxes on goods and services?
Keep it short and to the point. 4.53e+1. What is the difference between the highest and the second highest Taxes (in $) of Taxes on income?
Ensure brevity in your answer.  1.36e+1. What is the difference between the highest and the lowest Taxes (in $) in Taxes on revenue?
Make the answer very short. 1.14e+11. What is the difference between the highest and the lowest Taxes (in $) of Taxes on exports?
Your response must be concise. 2.55e+09. What is the difference between the highest and the lowest Taxes (in $) of Taxes on goods and services?
Make the answer very short. 4.84e+1. What is the difference between the highest and the lowest Taxes (in $) in Taxes on income?
Your response must be concise. 1.45e+1. 